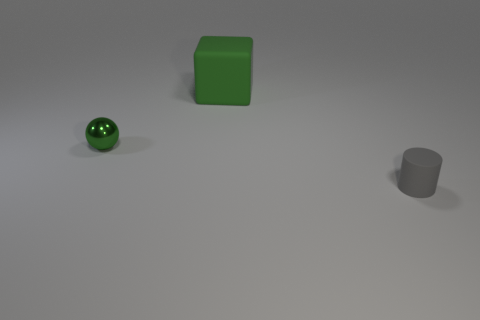Is there anything else that is the same size as the green matte object?
Keep it short and to the point. No. Is there any other thing that has the same shape as the small green metal thing?
Ensure brevity in your answer.  No. There is a small green metallic thing; how many large green things are to the left of it?
Your answer should be compact. 0. How many green blocks are made of the same material as the tiny gray cylinder?
Your answer should be compact. 1. What color is the cylinder that is made of the same material as the big cube?
Keep it short and to the point. Gray. The green thing left of the green object right of the object to the left of the large green matte thing is made of what material?
Give a very brief answer. Metal. There is a thing in front of the green shiny object; is its size the same as the green ball?
Provide a short and direct response. Yes. What number of large things are cubes or matte things?
Ensure brevity in your answer.  1. Is there a object of the same color as the ball?
Offer a terse response. Yes. The other object that is the same size as the gray thing is what shape?
Offer a very short reply. Sphere. 